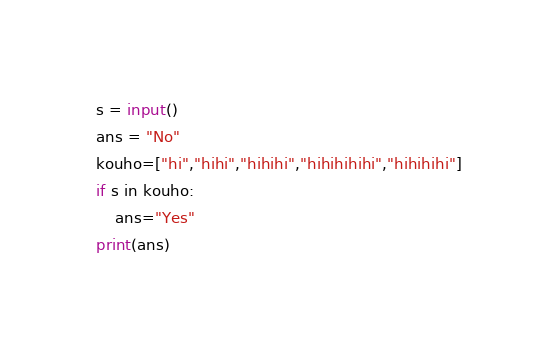Convert code to text. <code><loc_0><loc_0><loc_500><loc_500><_Python_>s = input()
ans = "No"
kouho=["hi","hihi","hihihi","hihihihihi","hihihihi"]
if s in kouho:
    ans="Yes"
print(ans)</code> 